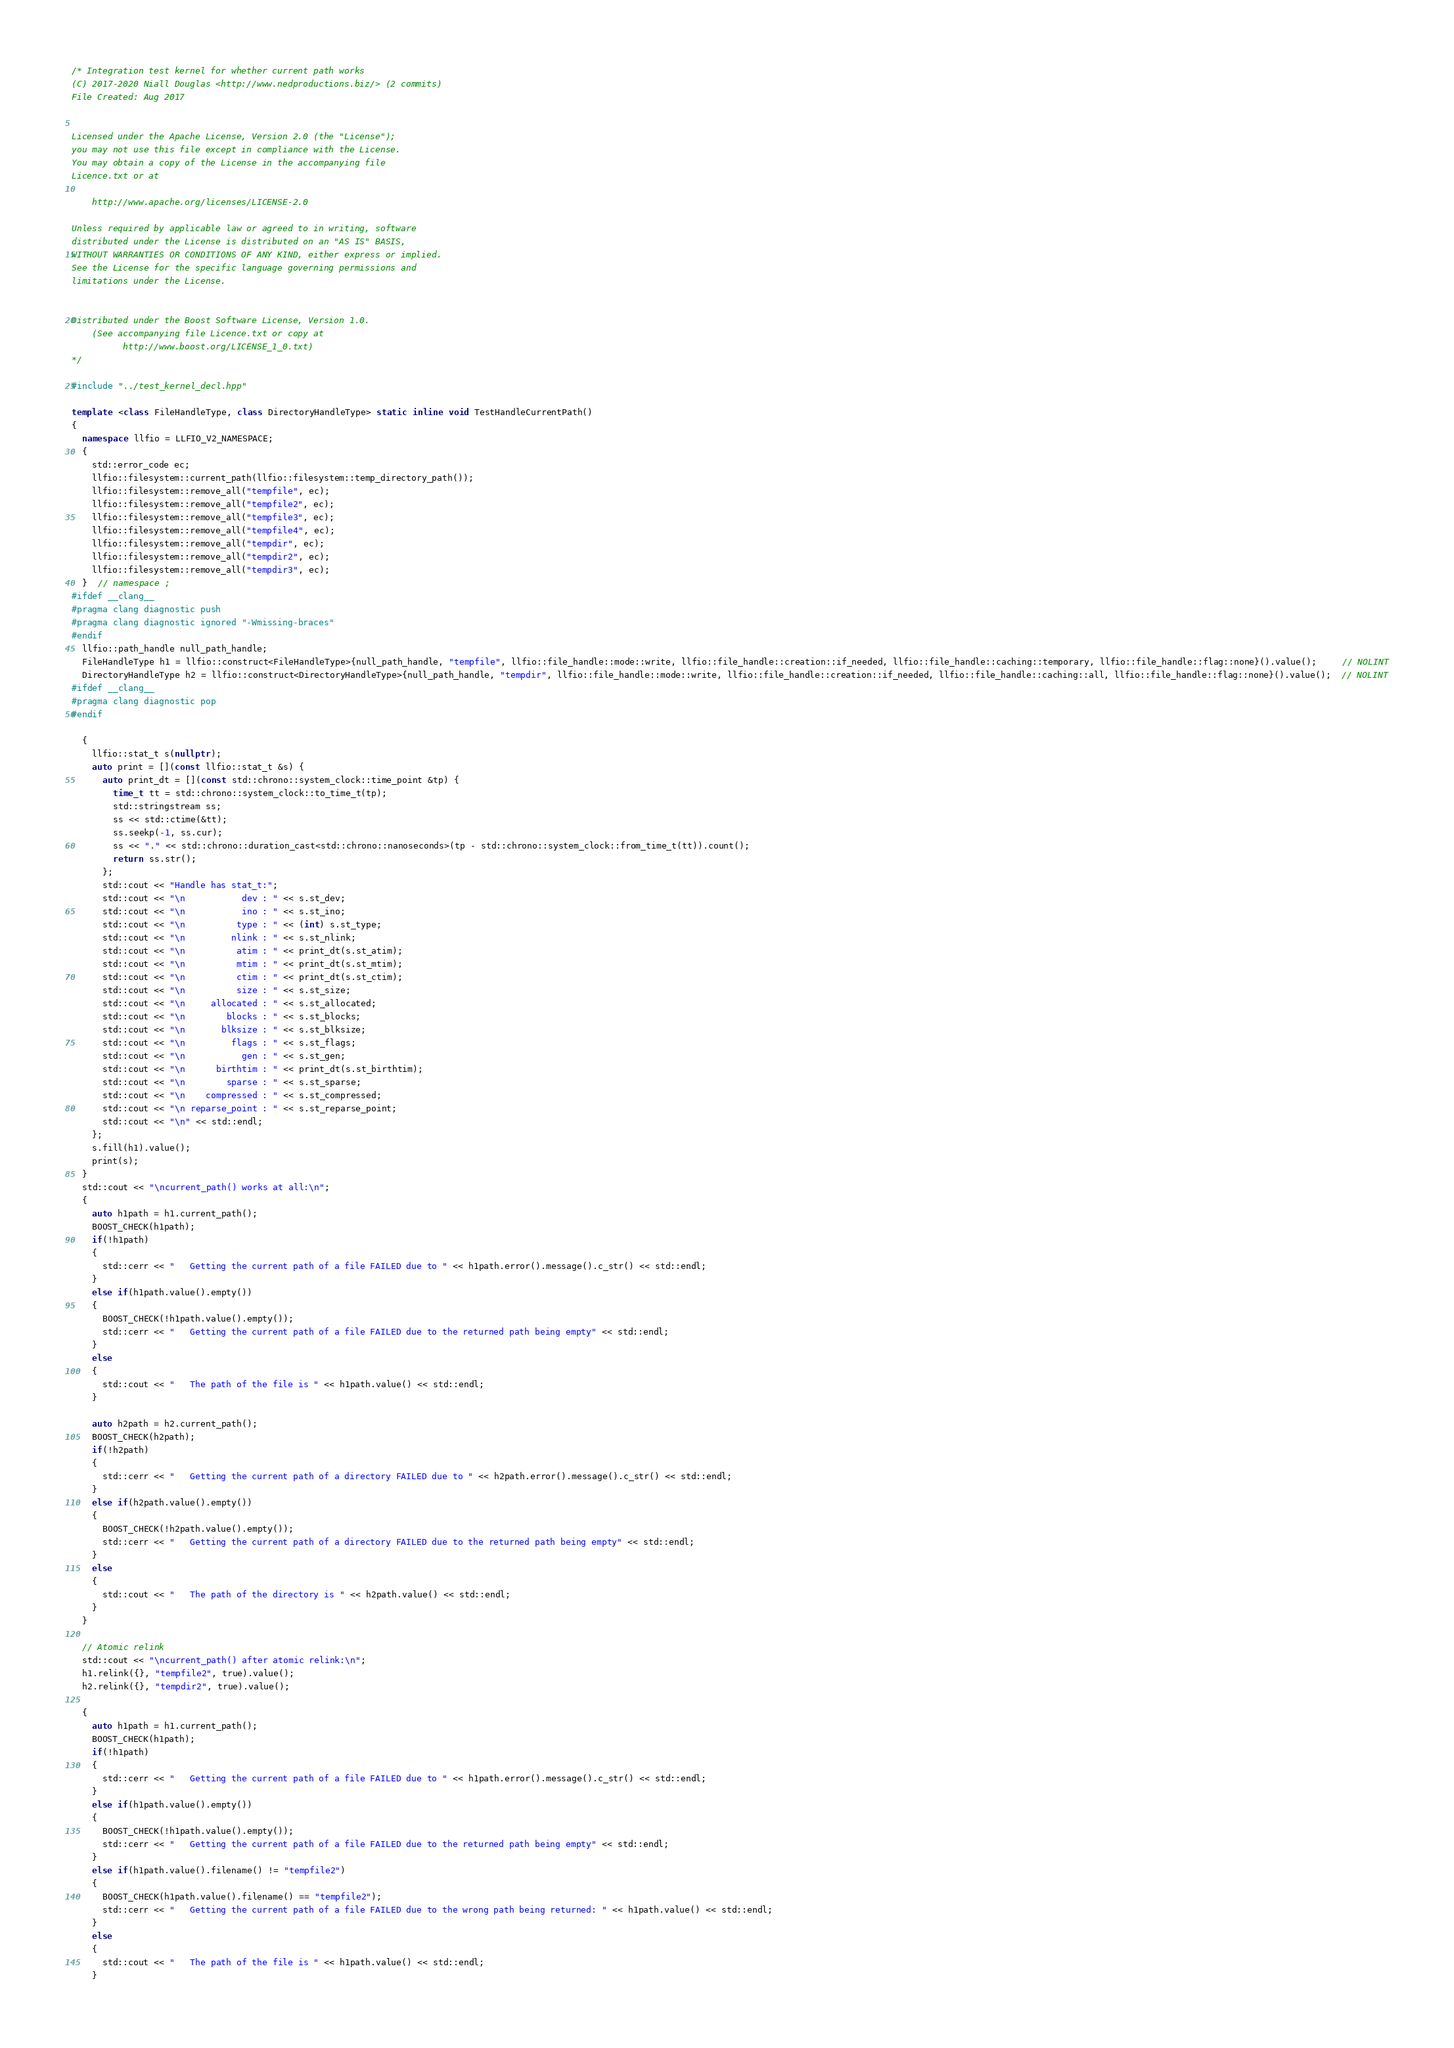Convert code to text. <code><loc_0><loc_0><loc_500><loc_500><_C++_>/* Integration test kernel for whether current path works
(C) 2017-2020 Niall Douglas <http://www.nedproductions.biz/> (2 commits)
File Created: Aug 2017


Licensed under the Apache License, Version 2.0 (the "License");
you may not use this file except in compliance with the License.
You may obtain a copy of the License in the accompanying file
Licence.txt or at

    http://www.apache.org/licenses/LICENSE-2.0

Unless required by applicable law or agreed to in writing, software
distributed under the License is distributed on an "AS IS" BASIS,
WITHOUT WARRANTIES OR CONDITIONS OF ANY KIND, either express or implied.
See the License for the specific language governing permissions and
limitations under the License.


Distributed under the Boost Software License, Version 1.0.
    (See accompanying file Licence.txt or copy at
          http://www.boost.org/LICENSE_1_0.txt)
*/

#include "../test_kernel_decl.hpp"

template <class FileHandleType, class DirectoryHandleType> static inline void TestHandleCurrentPath()
{
  namespace llfio = LLFIO_V2_NAMESPACE;
  {
    std::error_code ec;
    llfio::filesystem::current_path(llfio::filesystem::temp_directory_path());
    llfio::filesystem::remove_all("tempfile", ec);
    llfio::filesystem::remove_all("tempfile2", ec);
    llfio::filesystem::remove_all("tempfile3", ec);
    llfio::filesystem::remove_all("tempfile4", ec);
    llfio::filesystem::remove_all("tempdir", ec);
    llfio::filesystem::remove_all("tempdir2", ec);
    llfio::filesystem::remove_all("tempdir3", ec);
  }  // namespace ;
#ifdef __clang__
#pragma clang diagnostic push
#pragma clang diagnostic ignored "-Wmissing-braces"
#endif
  llfio::path_handle null_path_handle;
  FileHandleType h1 = llfio::construct<FileHandleType>{null_path_handle, "tempfile", llfio::file_handle::mode::write, llfio::file_handle::creation::if_needed, llfio::file_handle::caching::temporary, llfio::file_handle::flag::none}().value();     // NOLINT
  DirectoryHandleType h2 = llfio::construct<DirectoryHandleType>{null_path_handle, "tempdir", llfio::file_handle::mode::write, llfio::file_handle::creation::if_needed, llfio::file_handle::caching::all, llfio::file_handle::flag::none}().value();  // NOLINT
#ifdef __clang__
#pragma clang diagnostic pop
#endif

  {
    llfio::stat_t s(nullptr);
    auto print = [](const llfio::stat_t &s) {
      auto print_dt = [](const std::chrono::system_clock::time_point &tp) {
        time_t tt = std::chrono::system_clock::to_time_t(tp);
        std::stringstream ss;
        ss << std::ctime(&tt);
        ss.seekp(-1, ss.cur);
        ss << "." << std::chrono::duration_cast<std::chrono::nanoseconds>(tp - std::chrono::system_clock::from_time_t(tt)).count();
        return ss.str();
      };
      std::cout << "Handle has stat_t:";
      std::cout << "\n           dev : " << s.st_dev;
      std::cout << "\n           ino : " << s.st_ino;
      std::cout << "\n          type : " << (int) s.st_type;
      std::cout << "\n         nlink : " << s.st_nlink;
      std::cout << "\n          atim : " << print_dt(s.st_atim);
      std::cout << "\n          mtim : " << print_dt(s.st_mtim);
      std::cout << "\n          ctim : " << print_dt(s.st_ctim);
      std::cout << "\n          size : " << s.st_size;
      std::cout << "\n     allocated : " << s.st_allocated;
      std::cout << "\n        blocks : " << s.st_blocks;
      std::cout << "\n       blksize : " << s.st_blksize;
      std::cout << "\n         flags : " << s.st_flags;
      std::cout << "\n           gen : " << s.st_gen;
      std::cout << "\n      birthtim : " << print_dt(s.st_birthtim);
      std::cout << "\n        sparse : " << s.st_sparse;
      std::cout << "\n    compressed : " << s.st_compressed;
      std::cout << "\n reparse_point : " << s.st_reparse_point;
      std::cout << "\n" << std::endl;
    };
    s.fill(h1).value();
    print(s);
  }
  std::cout << "\ncurrent_path() works at all:\n";
  {
    auto h1path = h1.current_path();
    BOOST_CHECK(h1path);
    if(!h1path)
    {
      std::cerr << "   Getting the current path of a file FAILED due to " << h1path.error().message().c_str() << std::endl;
    }
    else if(h1path.value().empty())
    {
      BOOST_CHECK(!h1path.value().empty());
      std::cerr << "   Getting the current path of a file FAILED due to the returned path being empty" << std::endl;
    }
    else
    {
      std::cout << "   The path of the file is " << h1path.value() << std::endl;
    }

    auto h2path = h2.current_path();
    BOOST_CHECK(h2path);
    if(!h2path)
    {
      std::cerr << "   Getting the current path of a directory FAILED due to " << h2path.error().message().c_str() << std::endl;
    }
    else if(h2path.value().empty())
    {
      BOOST_CHECK(!h2path.value().empty());
      std::cerr << "   Getting the current path of a directory FAILED due to the returned path being empty" << std::endl;
    }
    else
    {
      std::cout << "   The path of the directory is " << h2path.value() << std::endl;
    }
  }

  // Atomic relink
  std::cout << "\ncurrent_path() after atomic relink:\n";
  h1.relink({}, "tempfile2", true).value();
  h2.relink({}, "tempdir2", true).value();

  {
    auto h1path = h1.current_path();
    BOOST_CHECK(h1path);
    if(!h1path)
    {
      std::cerr << "   Getting the current path of a file FAILED due to " << h1path.error().message().c_str() << std::endl;
    }
    else if(h1path.value().empty())
    {
      BOOST_CHECK(!h1path.value().empty());
      std::cerr << "   Getting the current path of a file FAILED due to the returned path being empty" << std::endl;
    }
    else if(h1path.value().filename() != "tempfile2")
    {
      BOOST_CHECK(h1path.value().filename() == "tempfile2");
      std::cerr << "   Getting the current path of a file FAILED due to the wrong path being returned: " << h1path.value() << std::endl;
    }
    else
    {
      std::cout << "   The path of the file is " << h1path.value() << std::endl;
    }
</code> 